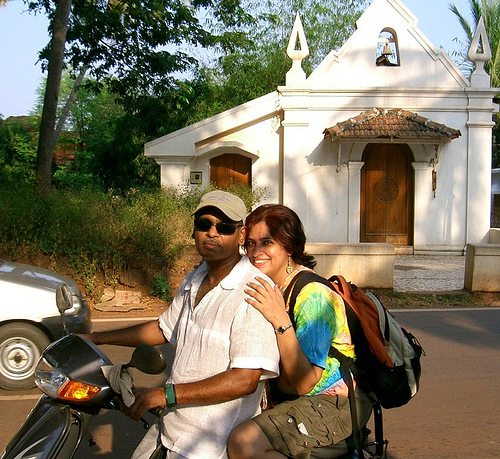What can be inferred about their relationship? The woman is holding onto the man driving the scooter, and they both appear comfortable and at ease with each other, suggesting familiarity and a close relationship. Their matching casual attire and shared activity could imply they are friends or a couple enjoying a leisurely trip together. 